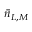<formula> <loc_0><loc_0><loc_500><loc_500>\bar { n } _ { L , M }</formula> 